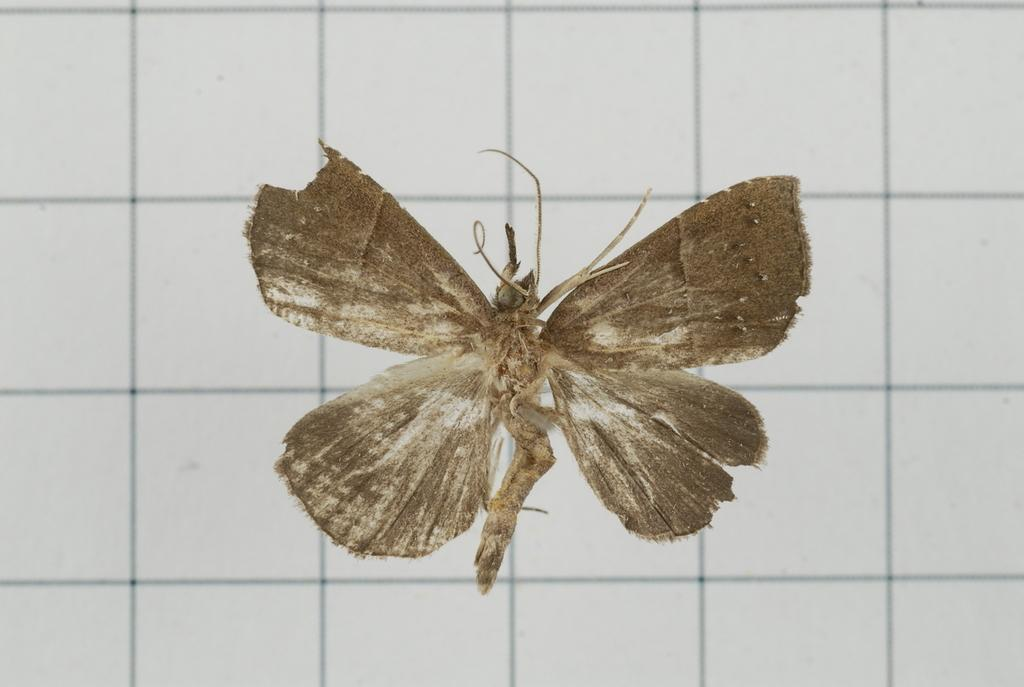What type of creature can be seen in the image? There is an insect in the image. What can be seen in the background of the image? There is a tile wall in the background of the image. How many teeth can be seen on the potato in the image? There is no potato present in the image, and therefore no teeth can be observed. 